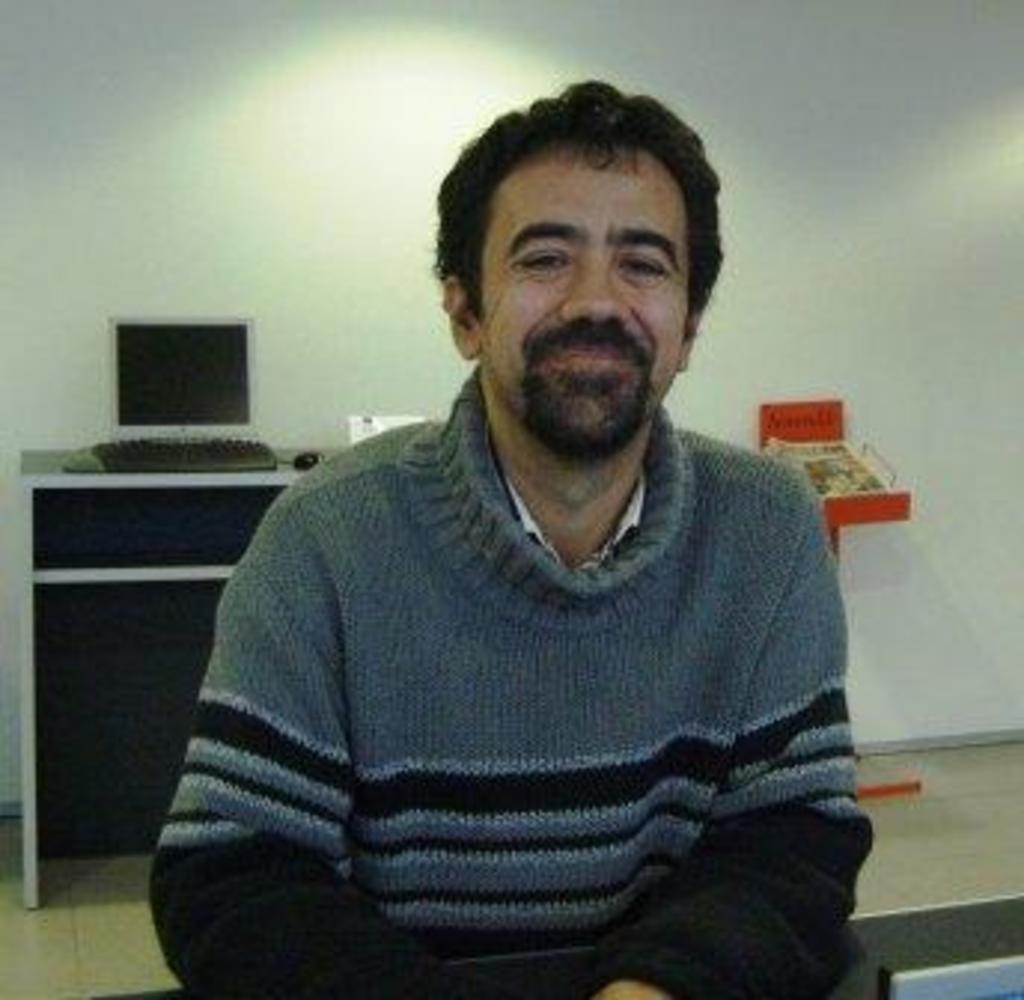Could you give a brief overview of what you see in this image? In this image a person is wearing a sweater. Behind him there is a table having a monitor, keyboard, mouse and few objects on it. Background there is a wall. 